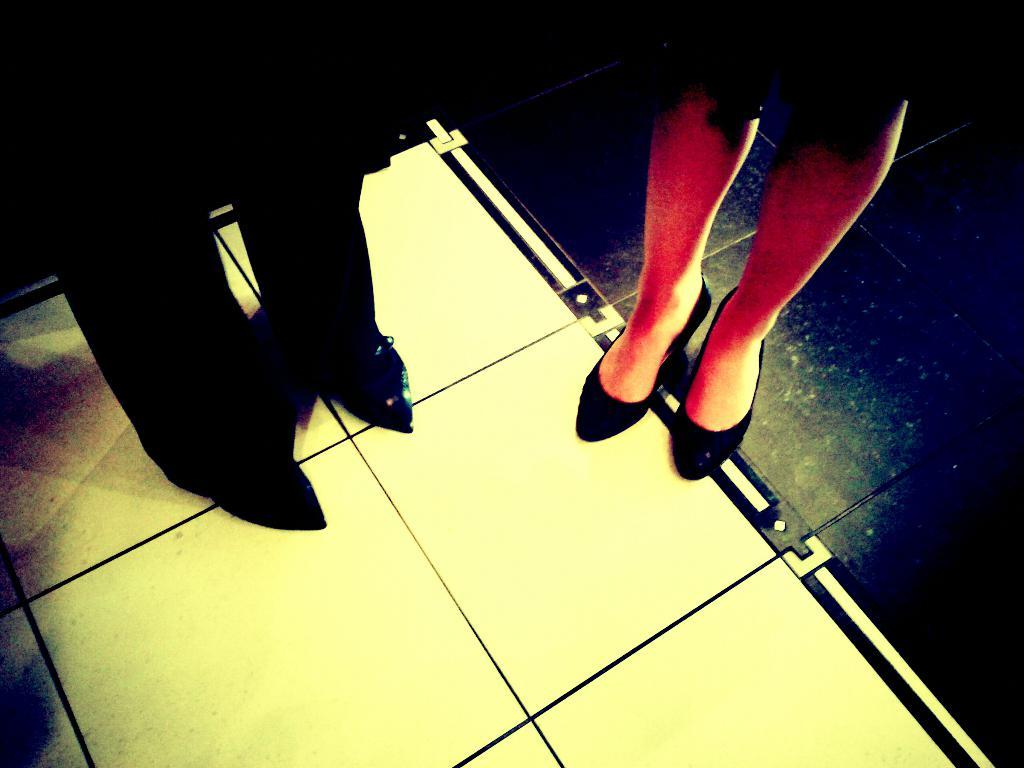What is visible in the image related to people? There are two people's legs visible in the image. Where are the legs located in the image? The legs are on the floor. What letters are being written on the vacation by the person in the image? There is no reference to letters, vacation, or a person writing anything in the image. 